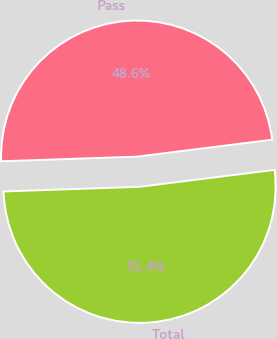Convert chart. <chart><loc_0><loc_0><loc_500><loc_500><pie_chart><fcel>Pass<fcel>Total<nl><fcel>48.56%<fcel>51.44%<nl></chart> 